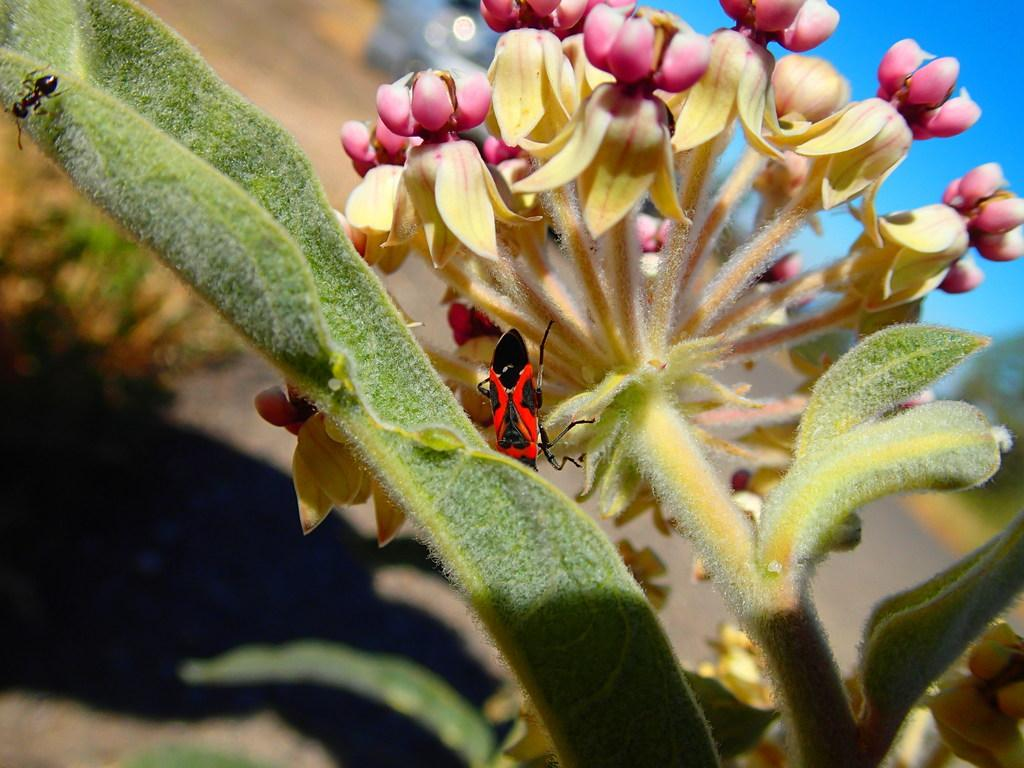What type of plant is visible in the image? There is a plant with buds and flowers in the image. Are there any creatures on the plant? Yes, there is an ant and an insect on the plant. How would you describe the background of the image? The background of the image is blurred. What type of ice can be seen melting on the plant in the image? There is no ice present in the image; it features a plant with buds and flowers, an ant, and an insect. 